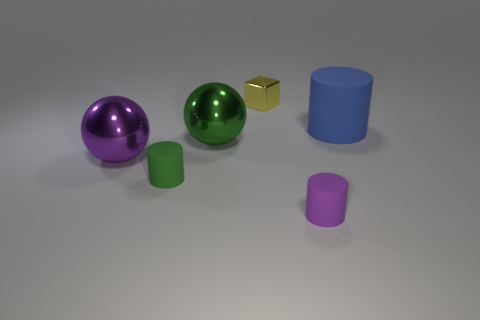Is there any other thing that has the same shape as the small metal thing?
Offer a very short reply. No. What number of cylinders are the same color as the block?
Give a very brief answer. 0. Is the shape of the small purple rubber thing the same as the big blue rubber thing?
Offer a very short reply. Yes. There is a matte thing that is to the left of the metal thing that is to the right of the big green ball; what is its size?
Provide a succinct answer. Small. Are there any blue objects of the same size as the purple metallic thing?
Provide a short and direct response. Yes. There is a green object that is behind the large purple metal object; is it the same size as the rubber cylinder that is left of the small metal block?
Provide a succinct answer. No. What is the shape of the big matte object that is right of the green rubber cylinder on the left side of the tiny metal cube?
Your answer should be compact. Cylinder. What number of big blue matte cylinders are to the right of the tiny purple rubber thing?
Your response must be concise. 1. There is a tiny thing that is made of the same material as the green cylinder; what color is it?
Provide a succinct answer. Purple. There is a green metallic ball; does it have the same size as the rubber cylinder that is behind the green cylinder?
Ensure brevity in your answer.  Yes. 